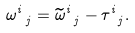Convert formula to latex. <formula><loc_0><loc_0><loc_500><loc_500>\omega ^ { i } _ { \ j } = \widetilde { \omega } ^ { i } _ { \ j } - \tau ^ { i } _ { \ j } .</formula> 